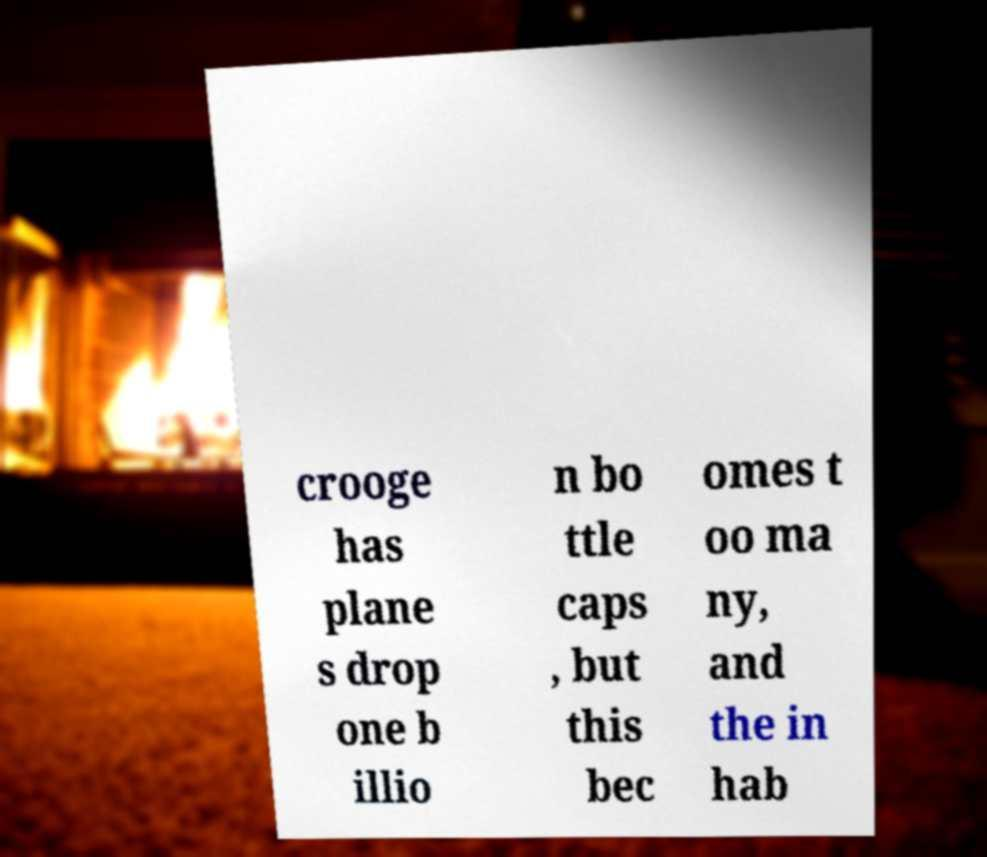Please read and relay the text visible in this image. What does it say? crooge has plane s drop one b illio n bo ttle caps , but this bec omes t oo ma ny, and the in hab 